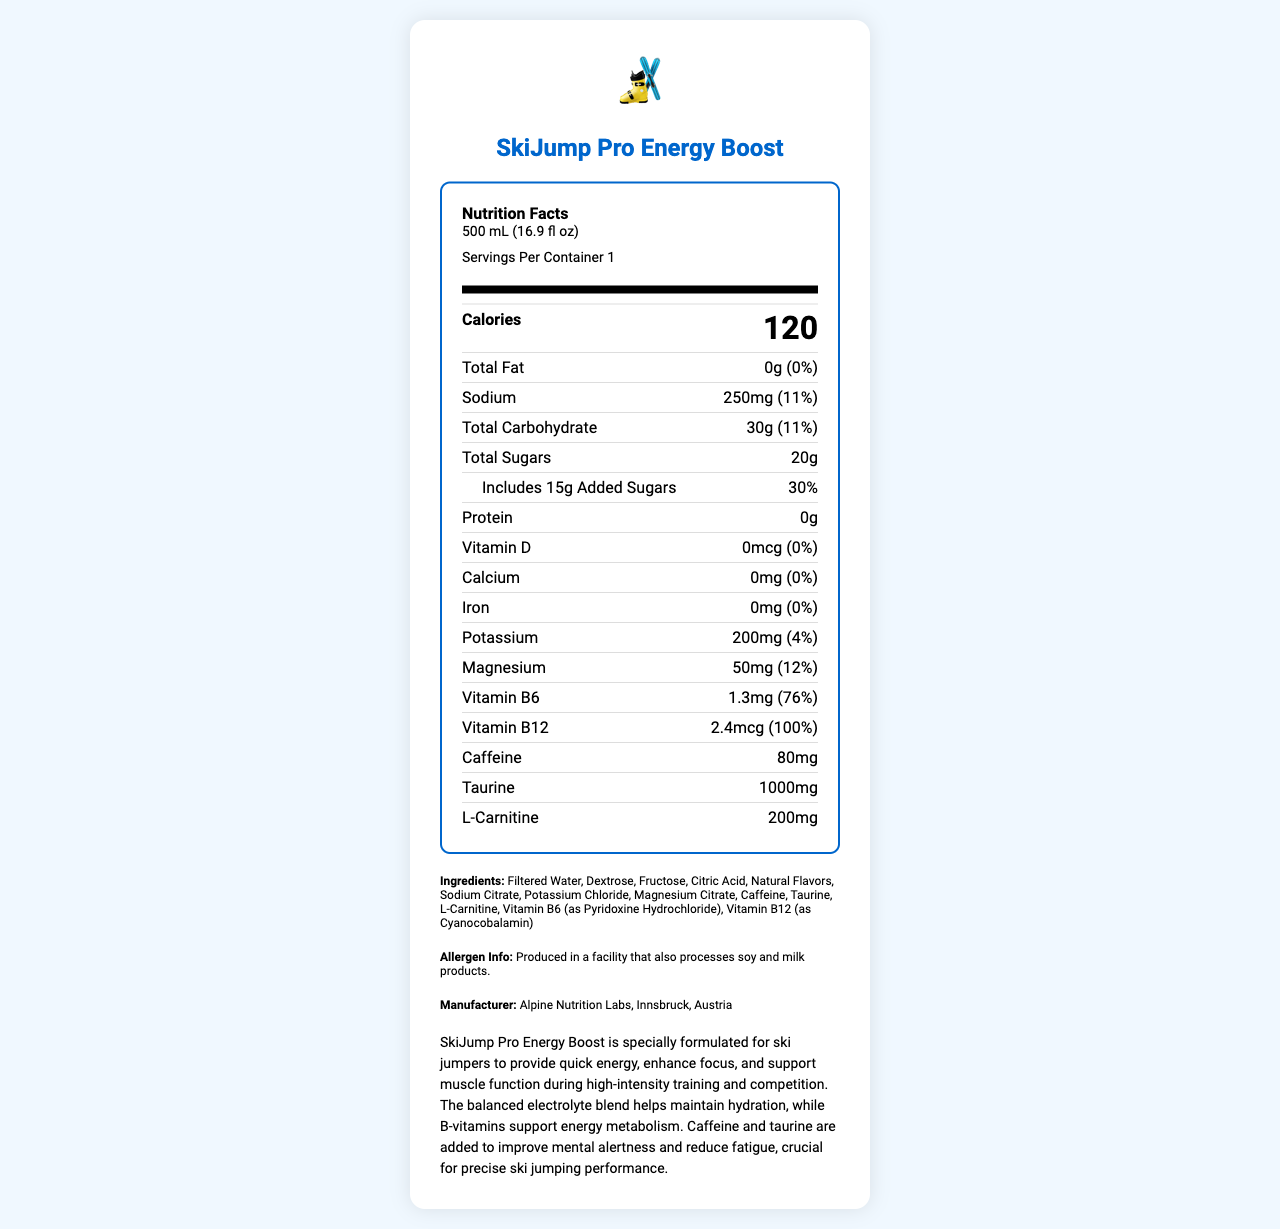what is the serving size for SkiJump Pro Energy Boost? The serving size is listed at the top of the nutrition facts label.
Answer: 500 mL (16.9 fl oz) how many calories does one serving of SkiJump Pro Energy Boost contain? The nutrition facts label lists the total calories per serving as 120.
Answer: 120 what is the amount of Vitamin B6 in the drink? The nutrient section shows that Vitamin B6 amount is 1.3mg.
Answer: 1.3mg how much sodium is there per serving? The nutrition facts label lists the sodium content as 250mg.
Answer: 250mg what ingredients are included in SkiJump Pro Energy Boost? The ingredients are listed at the bottom of the document.
Answer: Filtered Water, Dextrose, Fructose, Citric Acid, Natural Flavors, Sodium Citrate, Potassium Chloride, Magnesium Citrate, Caffeine, Taurine, L-Carnitine, Vitamin B6 (as Pyridoxine Hydrochloride), Vitamin B12 (as Cyanocobalamin) how much total fat does the drink have? The nutrition facts label lists the total fat content as 0g.
Answer: 0g what is the percentage of daily value for added sugars? The label shows that the added sugars daily value is 30%.
Answer: 30% does the drink contain any protein? The nutrition facts label shows 0g of protein.
Answer: No what beneficial effects does taurine provide in SkiJump Pro Energy Boost? The document only mentions taurine as an ingredient without detailing its effects.
Answer: Not enough information what is the function of Vitamin B12 in SkiJump Pro Energy Boost? The product description states that B-vitamins, including B12, support energy metabolism.
Answer: Vitamin B12 supports energy metabolism. which of these nutrients is present in the highest daily value percentage? A. Potassium B. Magnesium C. Vitamin B6 D. Vitamin B12 Vitamin B12 has a daily value of 100%, which is the highest among the listed options.
Answer: D. Vitamin B12 what is the caffeine content per serving? A. 50mg B. 60mg C. 80mg D. 100mg The nutrition facts label lists the caffeine content as 80mg per serving.
Answer: C. 80mg is SkiJump Pro Energy Boost suitable for someone with a soy allergy? The allergen info states that it is produced in a facility that also processes soy.
Answer: No summarize the main purpose of SkiJump Pro Energy Boost. The document describes the product's formulation and benefits for ski jumpers, mentioning its support for energy, focus, and muscle function, as well as detailed nutritional information.
Answer: SkiJump Pro Energy Boost is formulated to provide energy, enhance focus, and support muscle function during high-intensity training and competition for ski jumpers. It includes a balanced blend of electrolytes for hydration and B-vitamins for energy metabolism, along with caffeine and taurine for mental alertness and reduced fatigue. 